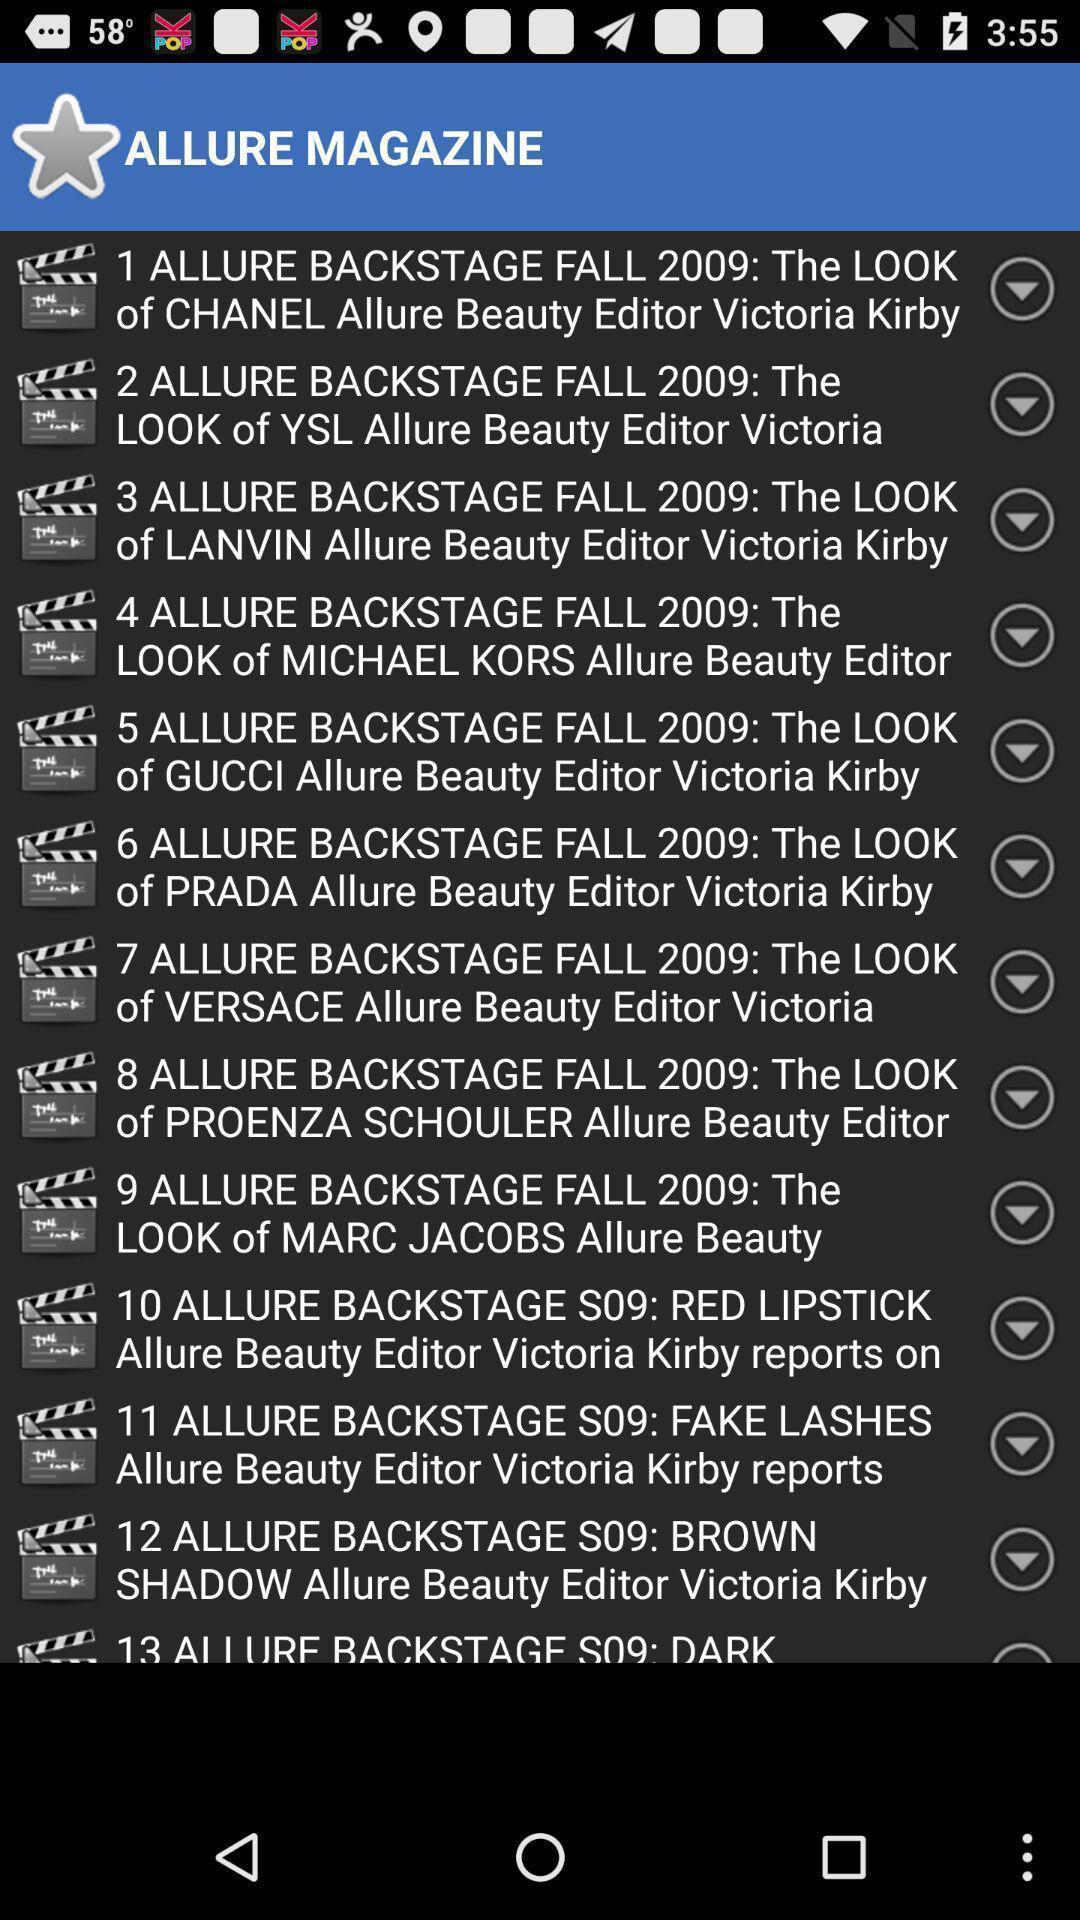Tell me what you see in this picture. Page with various options on beauty magazine. 